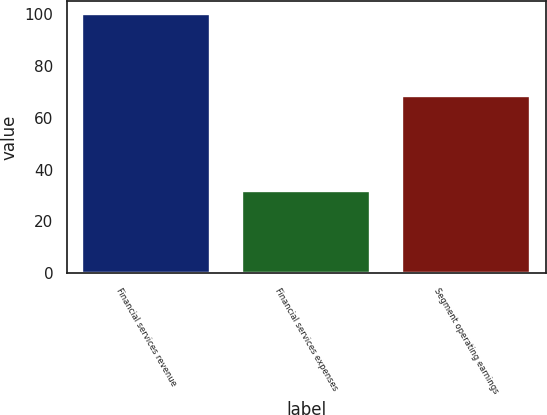Convert chart. <chart><loc_0><loc_0><loc_500><loc_500><bar_chart><fcel>Financial services revenue<fcel>Financial services expenses<fcel>Segment operating earnings<nl><fcel>100<fcel>31.7<fcel>68.3<nl></chart> 